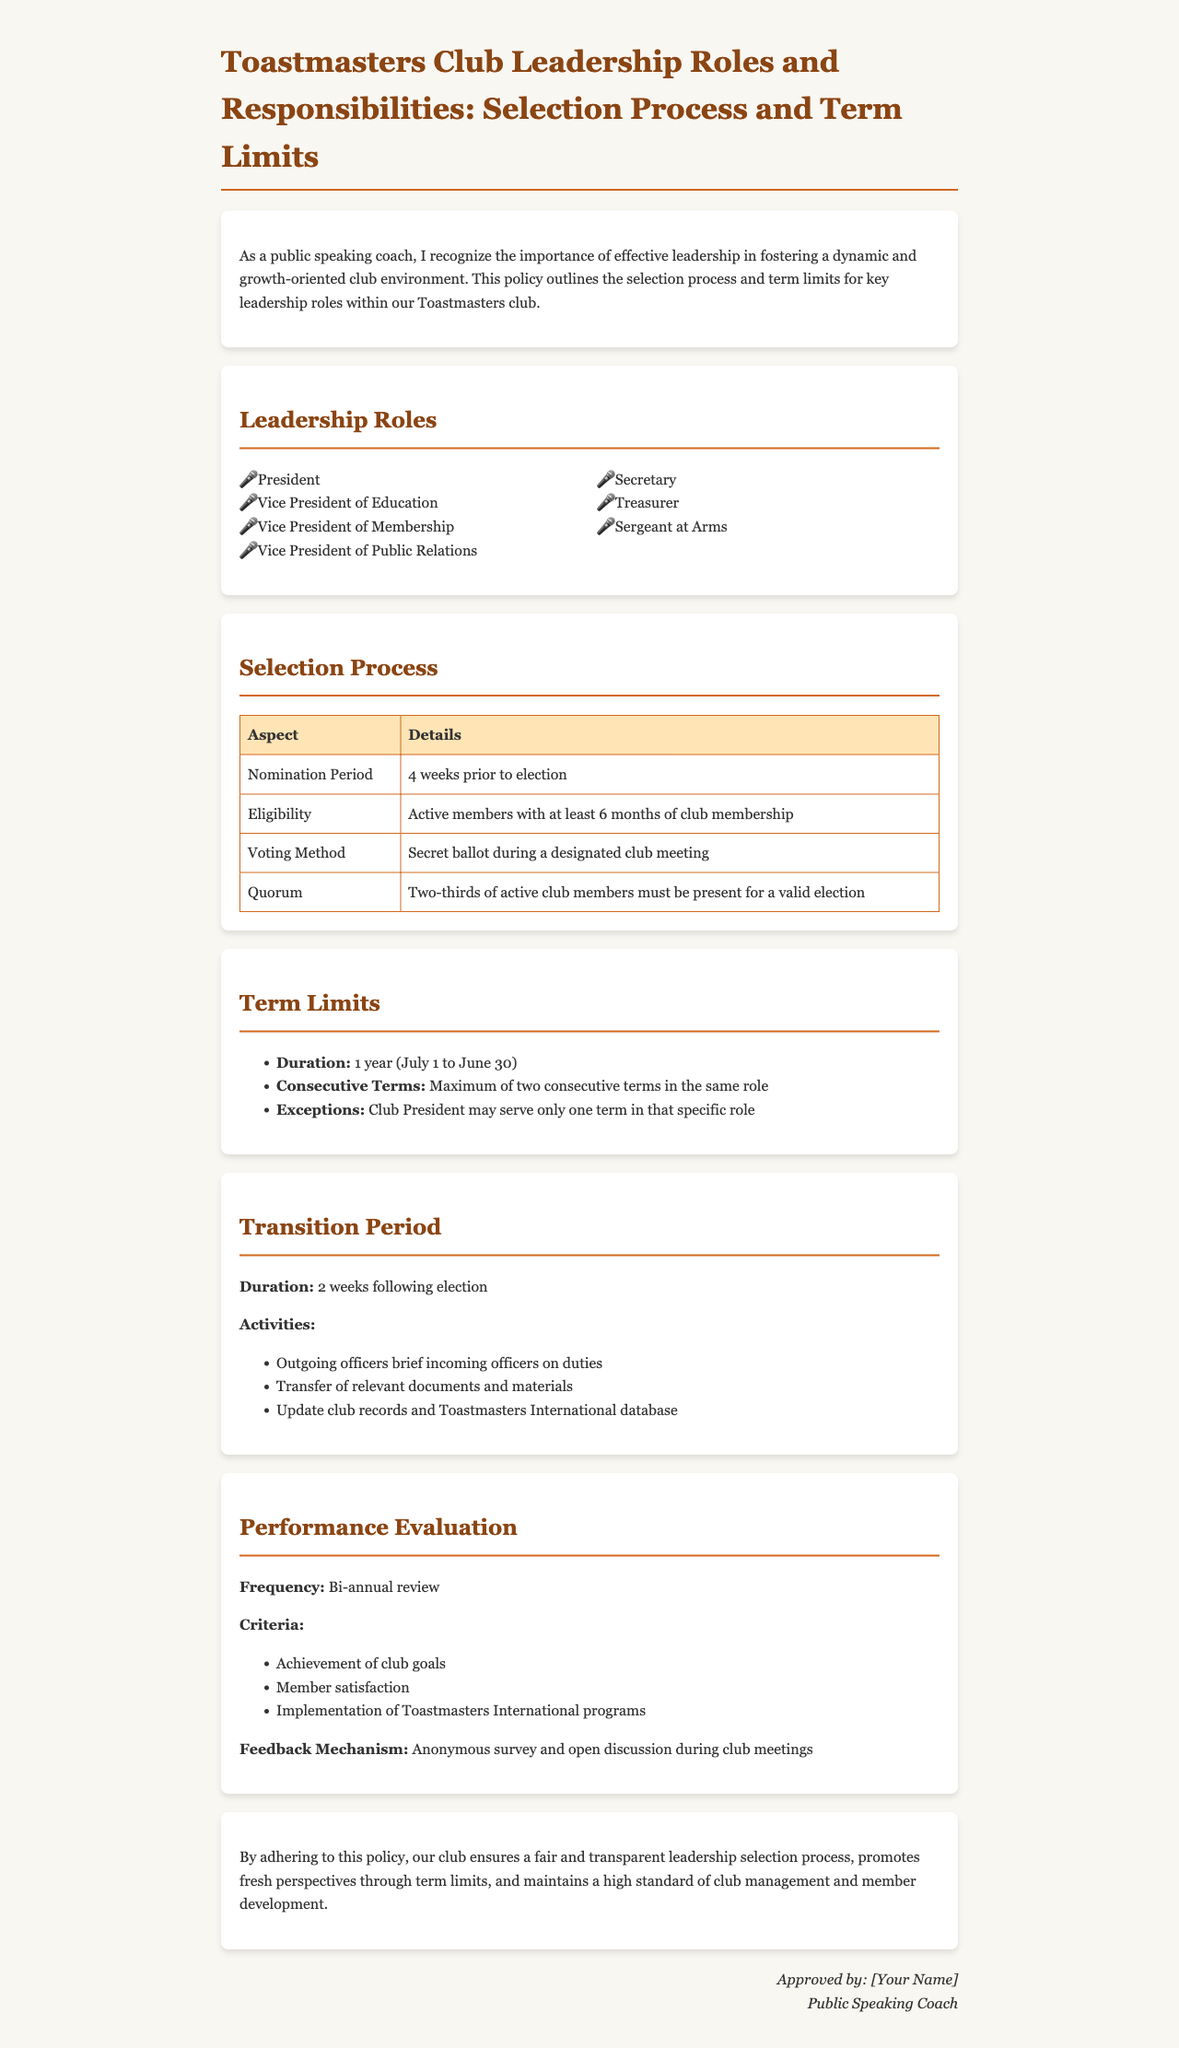What are the key leadership roles? The leadership roles listed in the document include roles such as President, Vice President of Education, and others.
Answer: President, Vice President of Education, Vice President of Membership, Vice President of Public Relations, Secretary, Treasurer, Sergeant at Arms What is the nomination period? The nomination period specifies the timeframe in which nominations for leadership roles are accepted before elections.
Answer: 4 weeks prior to election What is the quorum requirement for valid elections? The quorum requirement indicates the minimum number of members that must be present for the election to take place properly.
Answer: Two-thirds of active club members How long is the term duration for leadership roles? The term duration indicates the length of time a leader serves in their role before a new election occurs.
Answer: 1 year How many consecutive terms can a member serve in the same role? This question refers to the policy on the number of times a member can serve in the same leadership position without interruption.
Answer: Maximum of two consecutive terms What happens during the transition period? The transition period outlines activities that outgoing and incoming officers engage in to ensure smooth leadership transitions.
Answer: Outgoing officers brief incoming officers on duties, transfer of relevant documents and materials, and update club records How often is performance evaluated? Performance evaluation frequency indicates how regularly the leadership is assessed based on various criteria.
Answer: Bi-annual review What is the feedback mechanism for performance evaluation? This question addresses how feedback is collected regarding leadership performance in the club.
Answer: Anonymous survey and open discussion during club meetings 